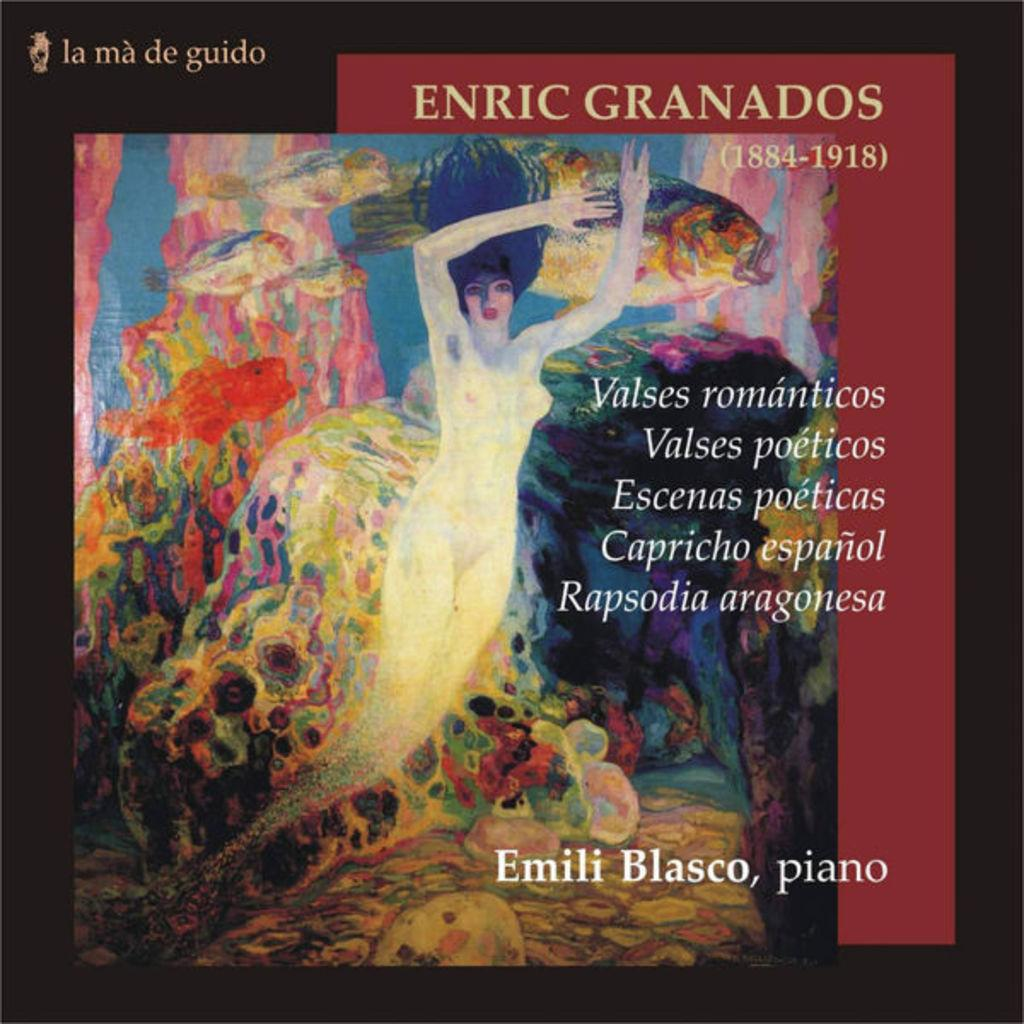Provide a one-sentence caption for the provided image. The album features Emili Blasco on the piano. 